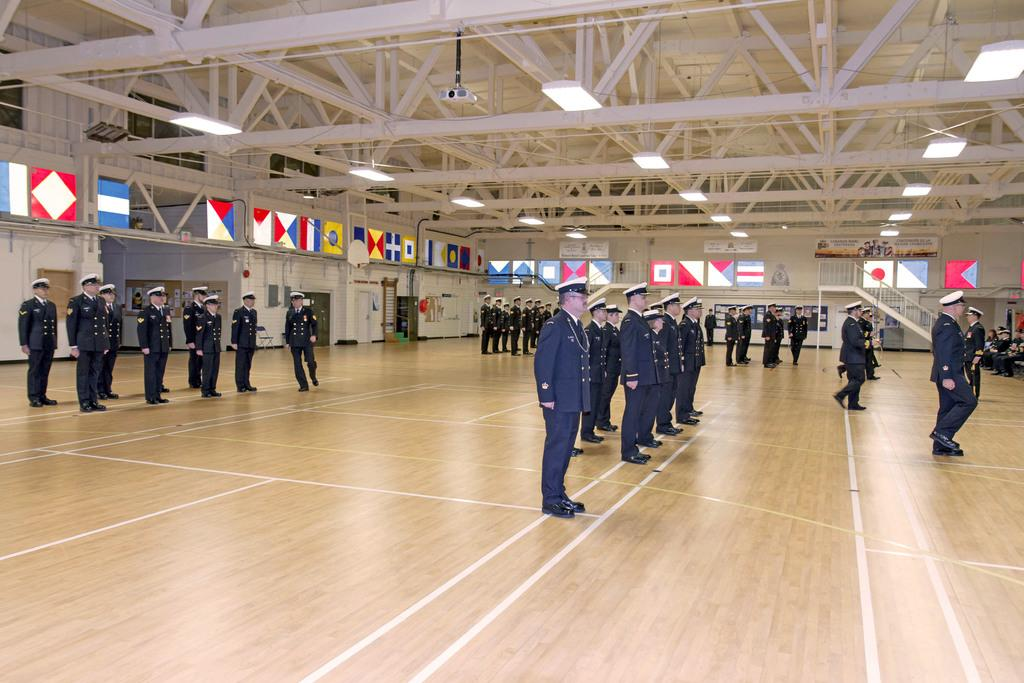What is the setting of the image? There are people standing in a hall. What are the people wearing in the image? The people are wearing caps and uniforms. Can you describe any architectural features in the hall? There are stairs and a railing at the back of the hall. What other objects can be seen in the image? There are flags and lights in the image. What type of bait is being used to catch fish in the image? There is no fishing or bait present in the image; it features people standing in a hall. Is this a birthday celebration, and if so, whose birthday is it? There is no indication in the image that it is a birthday celebration, so we cannot determine whose birthday it might be. 